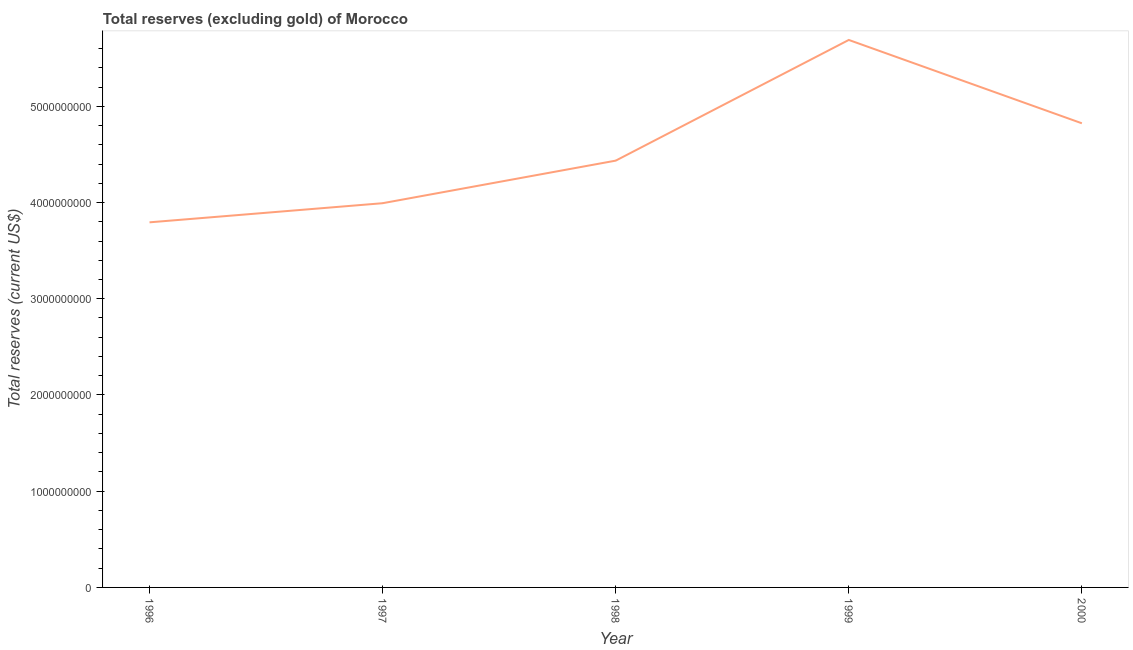What is the total reserves (excluding gold) in 2000?
Offer a terse response. 4.82e+09. Across all years, what is the maximum total reserves (excluding gold)?
Offer a very short reply. 5.69e+09. Across all years, what is the minimum total reserves (excluding gold)?
Provide a succinct answer. 3.79e+09. In which year was the total reserves (excluding gold) maximum?
Offer a very short reply. 1999. In which year was the total reserves (excluding gold) minimum?
Keep it short and to the point. 1996. What is the sum of the total reserves (excluding gold)?
Offer a terse response. 2.27e+1. What is the difference between the total reserves (excluding gold) in 1996 and 1998?
Offer a terse response. -6.41e+08. What is the average total reserves (excluding gold) per year?
Your answer should be compact. 4.55e+09. What is the median total reserves (excluding gold)?
Keep it short and to the point. 4.44e+09. In how many years, is the total reserves (excluding gold) greater than 2000000000 US$?
Your answer should be compact. 5. What is the ratio of the total reserves (excluding gold) in 1996 to that in 1997?
Make the answer very short. 0.95. Is the difference between the total reserves (excluding gold) in 1996 and 1998 greater than the difference between any two years?
Offer a terse response. No. What is the difference between the highest and the second highest total reserves (excluding gold)?
Make the answer very short. 8.66e+08. What is the difference between the highest and the lowest total reserves (excluding gold)?
Offer a terse response. 1.90e+09. How many lines are there?
Ensure brevity in your answer.  1. How many years are there in the graph?
Your response must be concise. 5. What is the difference between two consecutive major ticks on the Y-axis?
Give a very brief answer. 1.00e+09. Are the values on the major ticks of Y-axis written in scientific E-notation?
Offer a terse response. No. Does the graph contain grids?
Your answer should be very brief. No. What is the title of the graph?
Offer a terse response. Total reserves (excluding gold) of Morocco. What is the label or title of the Y-axis?
Give a very brief answer. Total reserves (current US$). What is the Total reserves (current US$) in 1996?
Provide a succinct answer. 3.79e+09. What is the Total reserves (current US$) in 1997?
Your response must be concise. 3.99e+09. What is the Total reserves (current US$) in 1998?
Offer a very short reply. 4.44e+09. What is the Total reserves (current US$) in 1999?
Offer a terse response. 5.69e+09. What is the Total reserves (current US$) in 2000?
Make the answer very short. 4.82e+09. What is the difference between the Total reserves (current US$) in 1996 and 1997?
Offer a terse response. -1.99e+08. What is the difference between the Total reserves (current US$) in 1996 and 1998?
Give a very brief answer. -6.41e+08. What is the difference between the Total reserves (current US$) in 1996 and 1999?
Your response must be concise. -1.90e+09. What is the difference between the Total reserves (current US$) in 1996 and 2000?
Ensure brevity in your answer.  -1.03e+09. What is the difference between the Total reserves (current US$) in 1997 and 1998?
Offer a very short reply. -4.42e+08. What is the difference between the Total reserves (current US$) in 1997 and 1999?
Your answer should be very brief. -1.70e+09. What is the difference between the Total reserves (current US$) in 1997 and 2000?
Keep it short and to the point. -8.30e+08. What is the difference between the Total reserves (current US$) in 1998 and 1999?
Your answer should be compact. -1.25e+09. What is the difference between the Total reserves (current US$) in 1998 and 2000?
Ensure brevity in your answer.  -3.88e+08. What is the difference between the Total reserves (current US$) in 1999 and 2000?
Ensure brevity in your answer.  8.66e+08. What is the ratio of the Total reserves (current US$) in 1996 to that in 1998?
Provide a succinct answer. 0.85. What is the ratio of the Total reserves (current US$) in 1996 to that in 1999?
Your response must be concise. 0.67. What is the ratio of the Total reserves (current US$) in 1996 to that in 2000?
Offer a terse response. 0.79. What is the ratio of the Total reserves (current US$) in 1997 to that in 1999?
Your answer should be very brief. 0.7. What is the ratio of the Total reserves (current US$) in 1997 to that in 2000?
Offer a terse response. 0.83. What is the ratio of the Total reserves (current US$) in 1998 to that in 1999?
Make the answer very short. 0.78. What is the ratio of the Total reserves (current US$) in 1999 to that in 2000?
Your response must be concise. 1.18. 